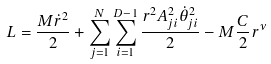<formula> <loc_0><loc_0><loc_500><loc_500>L = \frac { M \dot { r } ^ { 2 } } { 2 } + \sum _ { j = 1 } ^ { N } \sum _ { i = 1 } ^ { D - 1 } \frac { r ^ { 2 } A _ { j i } ^ { 2 } \dot { \theta } _ { j i } ^ { 2 } } { 2 } - M \frac { C } { 2 } r ^ { \nu }</formula> 